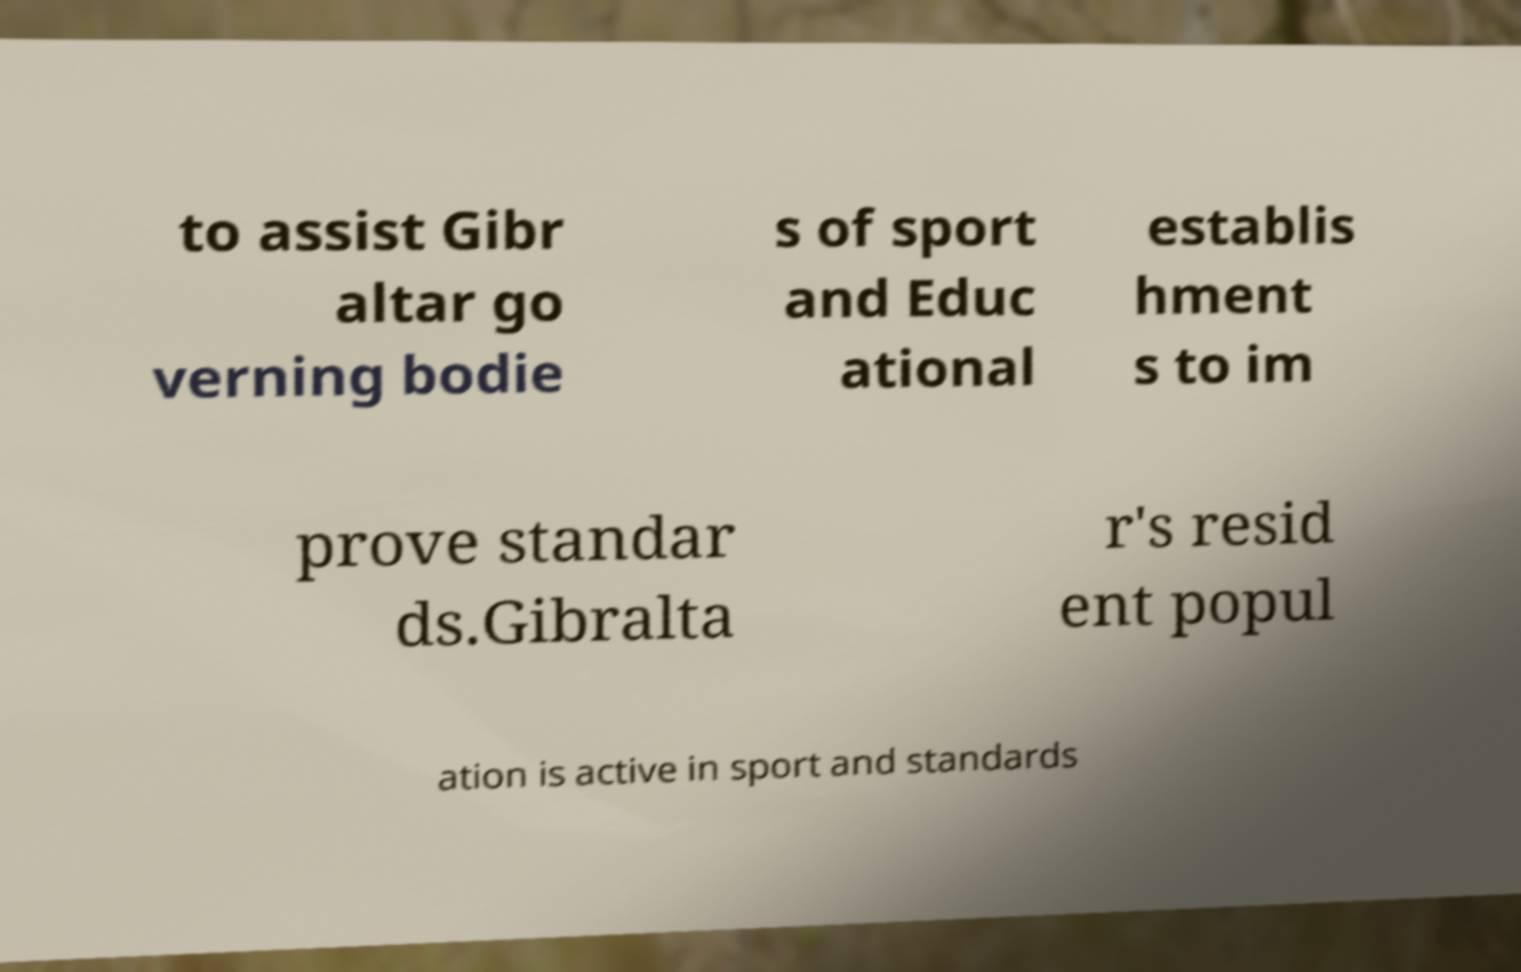Please identify and transcribe the text found in this image. to assist Gibr altar go verning bodie s of sport and Educ ational establis hment s to im prove standar ds.Gibralta r's resid ent popul ation is active in sport and standards 